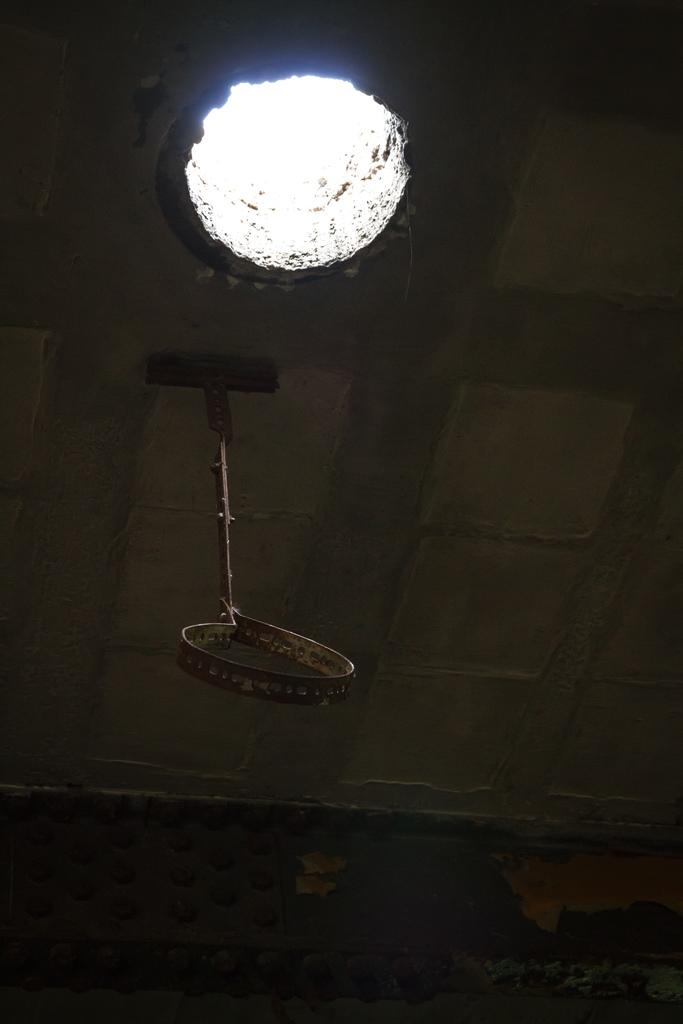What is hanging from the ceiling in the image? Unfortunately, the provided facts do not specify what the object hanging from the ceiling is. Can you describe the hole in the image? The facts only mention the presence of a hole, but do not provide any details about its size, shape, or location. What type of society can be seen interacting with the stone on the farm in the image? There is no mention of a society, stone, or farm in the provided facts, so this question cannot be answered based on the information given. 